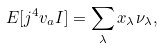<formula> <loc_0><loc_0><loc_500><loc_500>E [ j ^ { 4 } v _ { a } I ] = \sum _ { \lambda } x _ { \lambda } \nu _ { \lambda } ,</formula> 